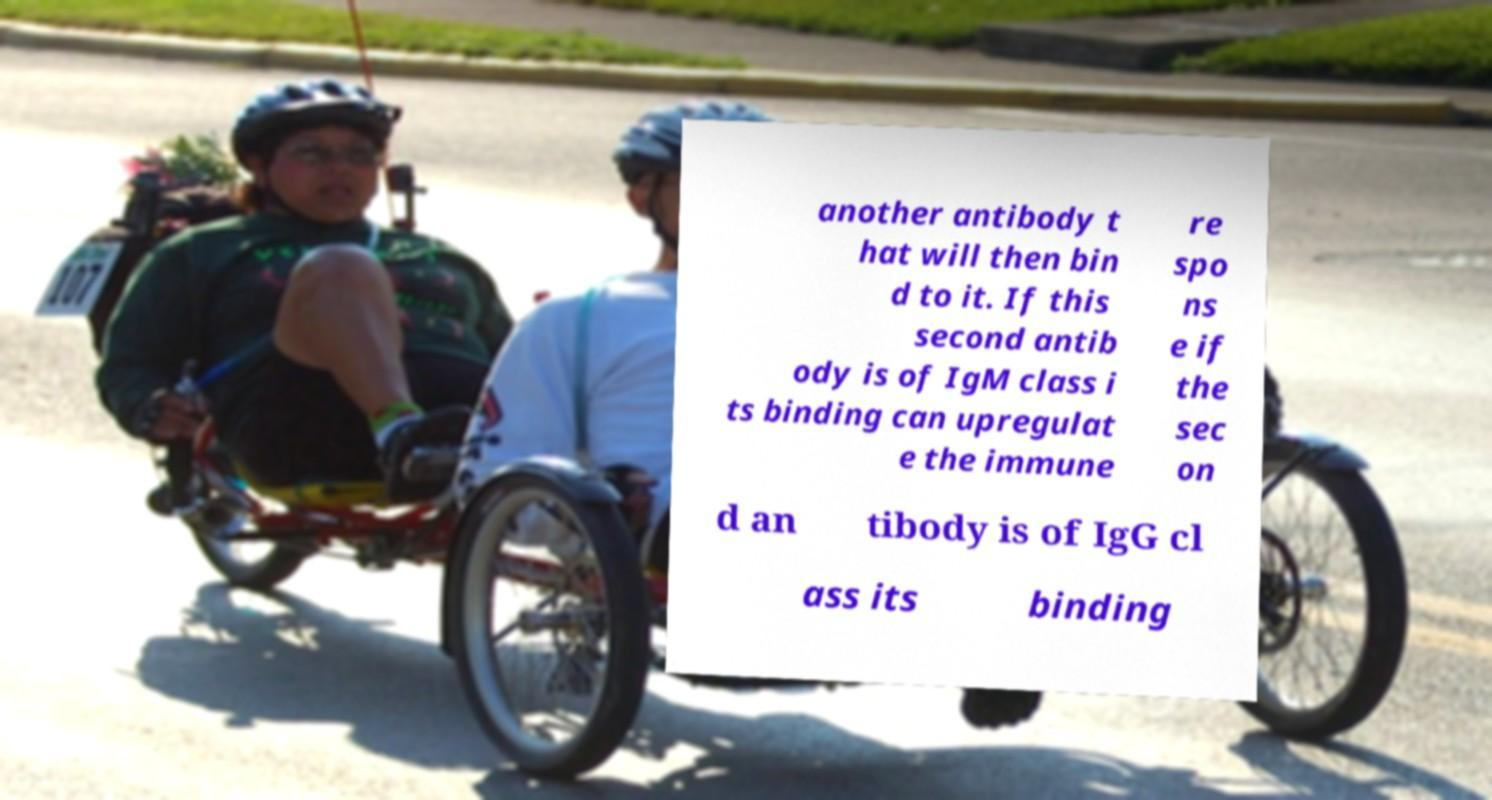There's text embedded in this image that I need extracted. Can you transcribe it verbatim? another antibody t hat will then bin d to it. If this second antib ody is of IgM class i ts binding can upregulat e the immune re spo ns e if the sec on d an tibody is of IgG cl ass its binding 